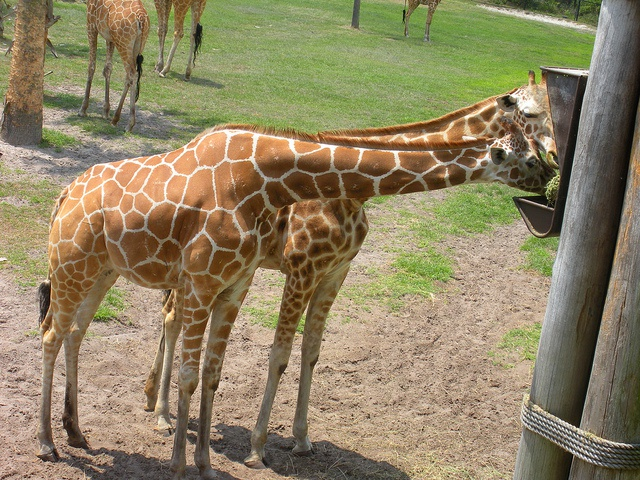Describe the objects in this image and their specific colors. I can see giraffe in gray, maroon, and tan tones, giraffe in gray, olive, and maroon tones, giraffe in gray and olive tones, and giraffe in gray and olive tones in this image. 